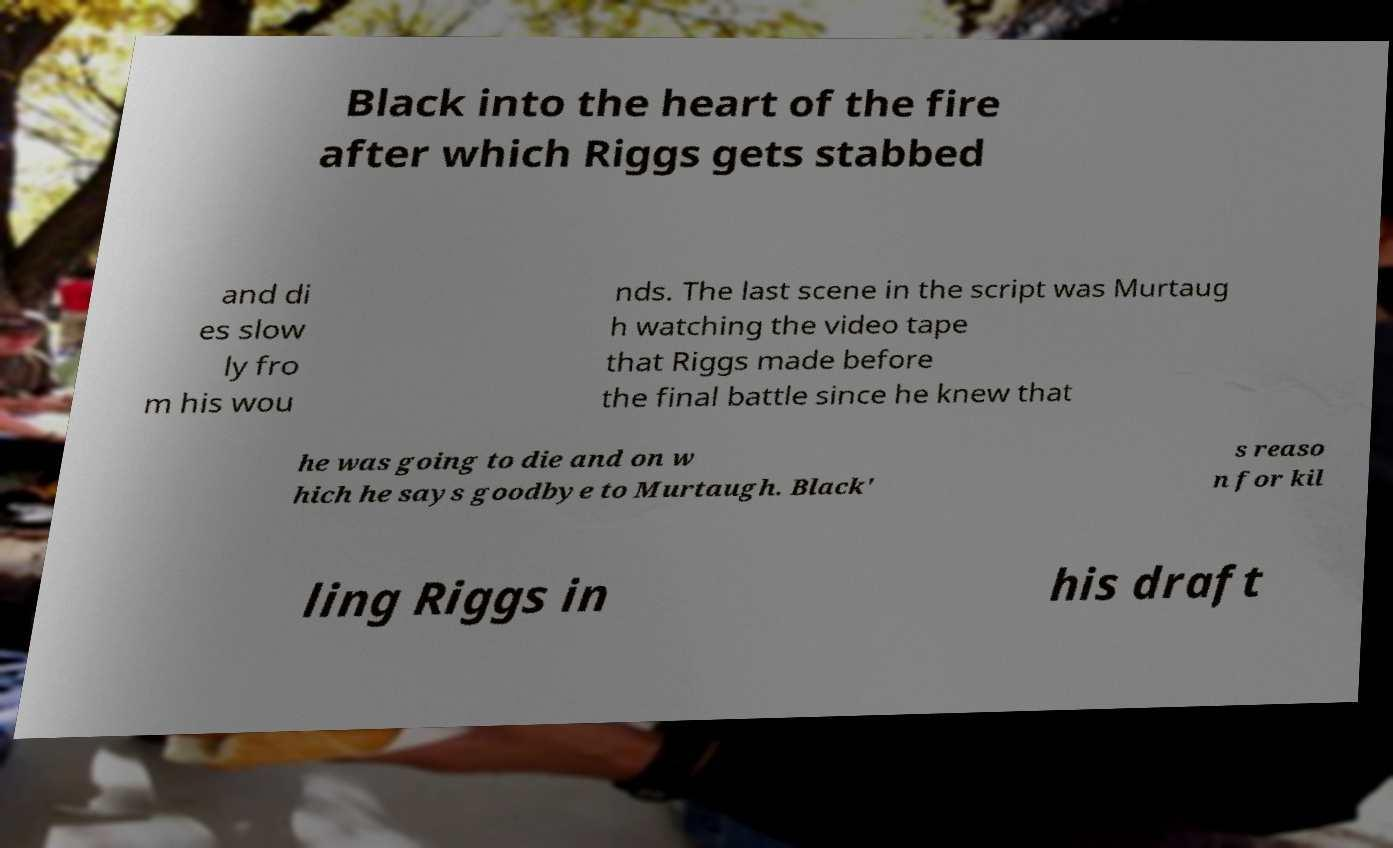Please identify and transcribe the text found in this image. Black into the heart of the fire after which Riggs gets stabbed and di es slow ly fro m his wou nds. The last scene in the script was Murtaug h watching the video tape that Riggs made before the final battle since he knew that he was going to die and on w hich he says goodbye to Murtaugh. Black' s reaso n for kil ling Riggs in his draft 